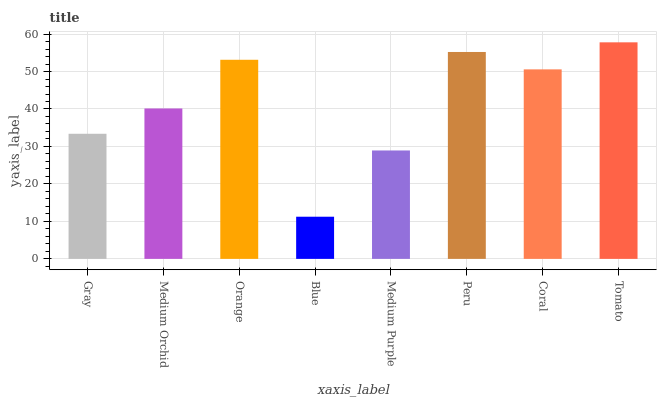Is Blue the minimum?
Answer yes or no. Yes. Is Tomato the maximum?
Answer yes or no. Yes. Is Medium Orchid the minimum?
Answer yes or no. No. Is Medium Orchid the maximum?
Answer yes or no. No. Is Medium Orchid greater than Gray?
Answer yes or no. Yes. Is Gray less than Medium Orchid?
Answer yes or no. Yes. Is Gray greater than Medium Orchid?
Answer yes or no. No. Is Medium Orchid less than Gray?
Answer yes or no. No. Is Coral the high median?
Answer yes or no. Yes. Is Medium Orchid the low median?
Answer yes or no. Yes. Is Medium Orchid the high median?
Answer yes or no. No. Is Blue the low median?
Answer yes or no. No. 